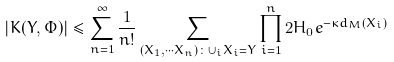<formula> <loc_0><loc_0><loc_500><loc_500>| K ( Y , \Phi ) | \leq \sum _ { n = 1 } ^ { \infty } \frac { 1 } { n ! } \sum _ { ( X _ { 1 } , \cdots X _ { n } ) \colon \cup _ { i } X _ { i } = Y } \prod _ { i = 1 } ^ { n } 2 H _ { 0 } e ^ { - \kappa d _ { M } ( X _ { i } ) }</formula> 